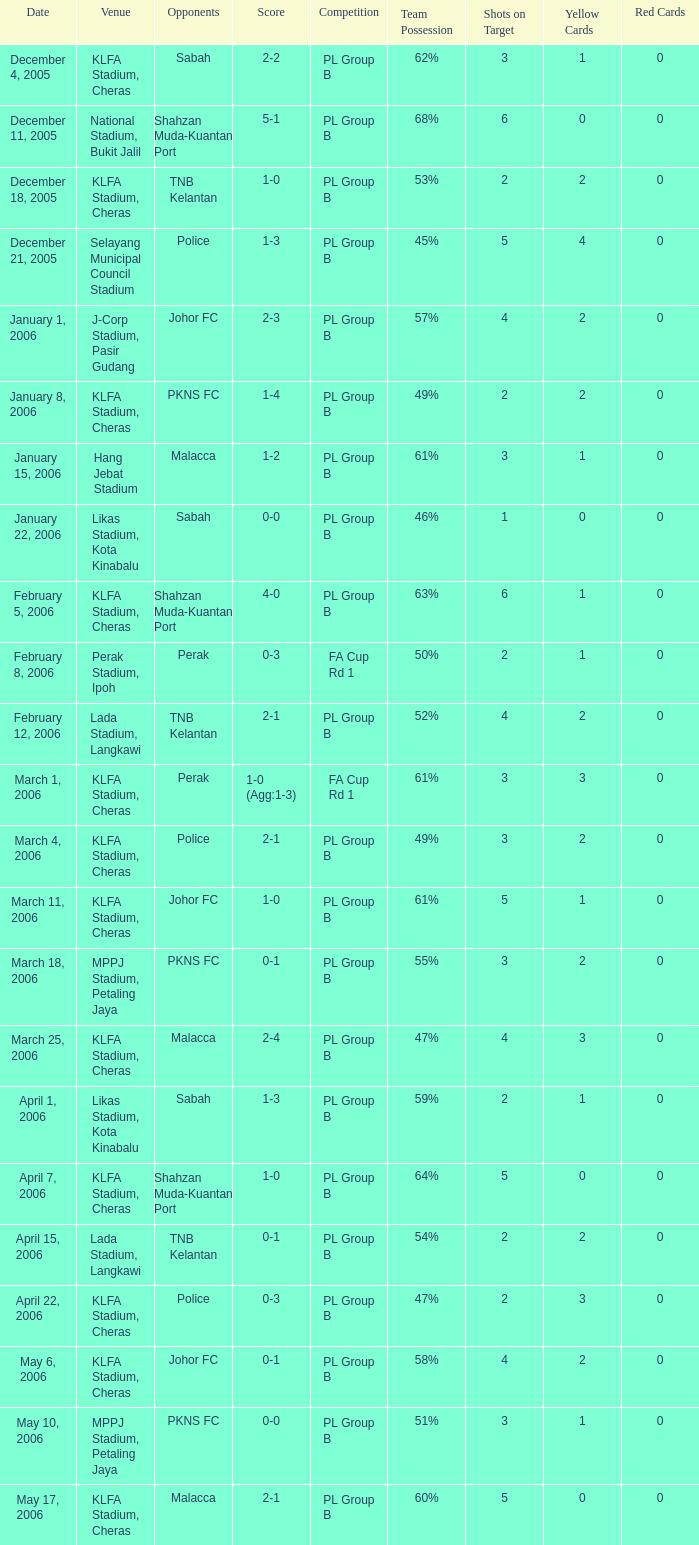Who competed on may 6, 2006? Johor FC. 